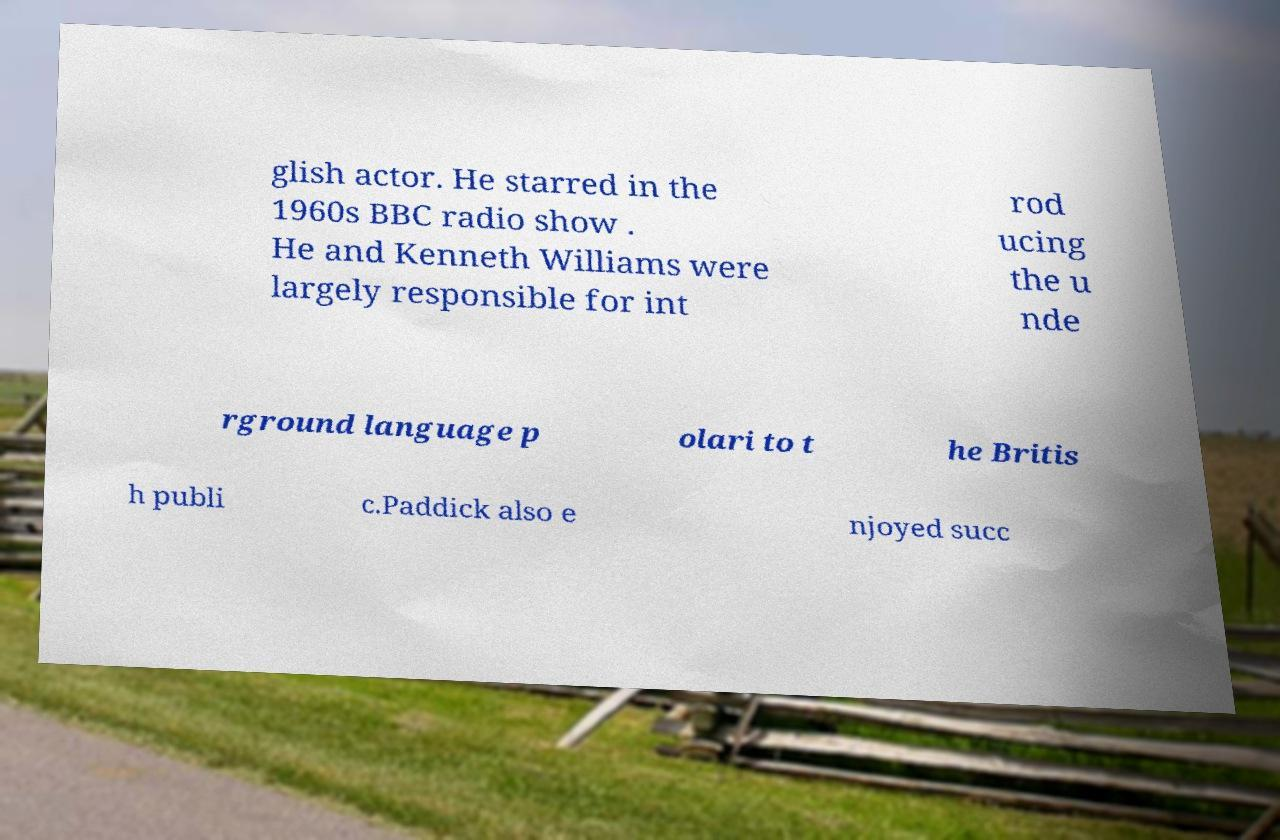Could you extract and type out the text from this image? glish actor. He starred in the 1960s BBC radio show . He and Kenneth Williams were largely responsible for int rod ucing the u nde rground language p olari to t he Britis h publi c.Paddick also e njoyed succ 